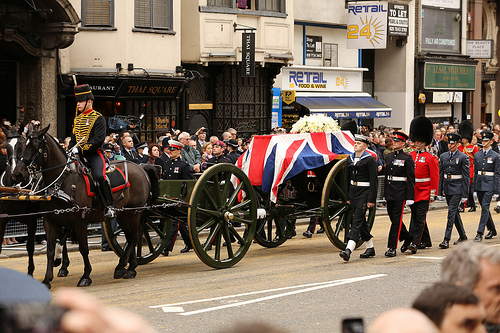What's the horse pulling? The horse is pulling a wagon. 